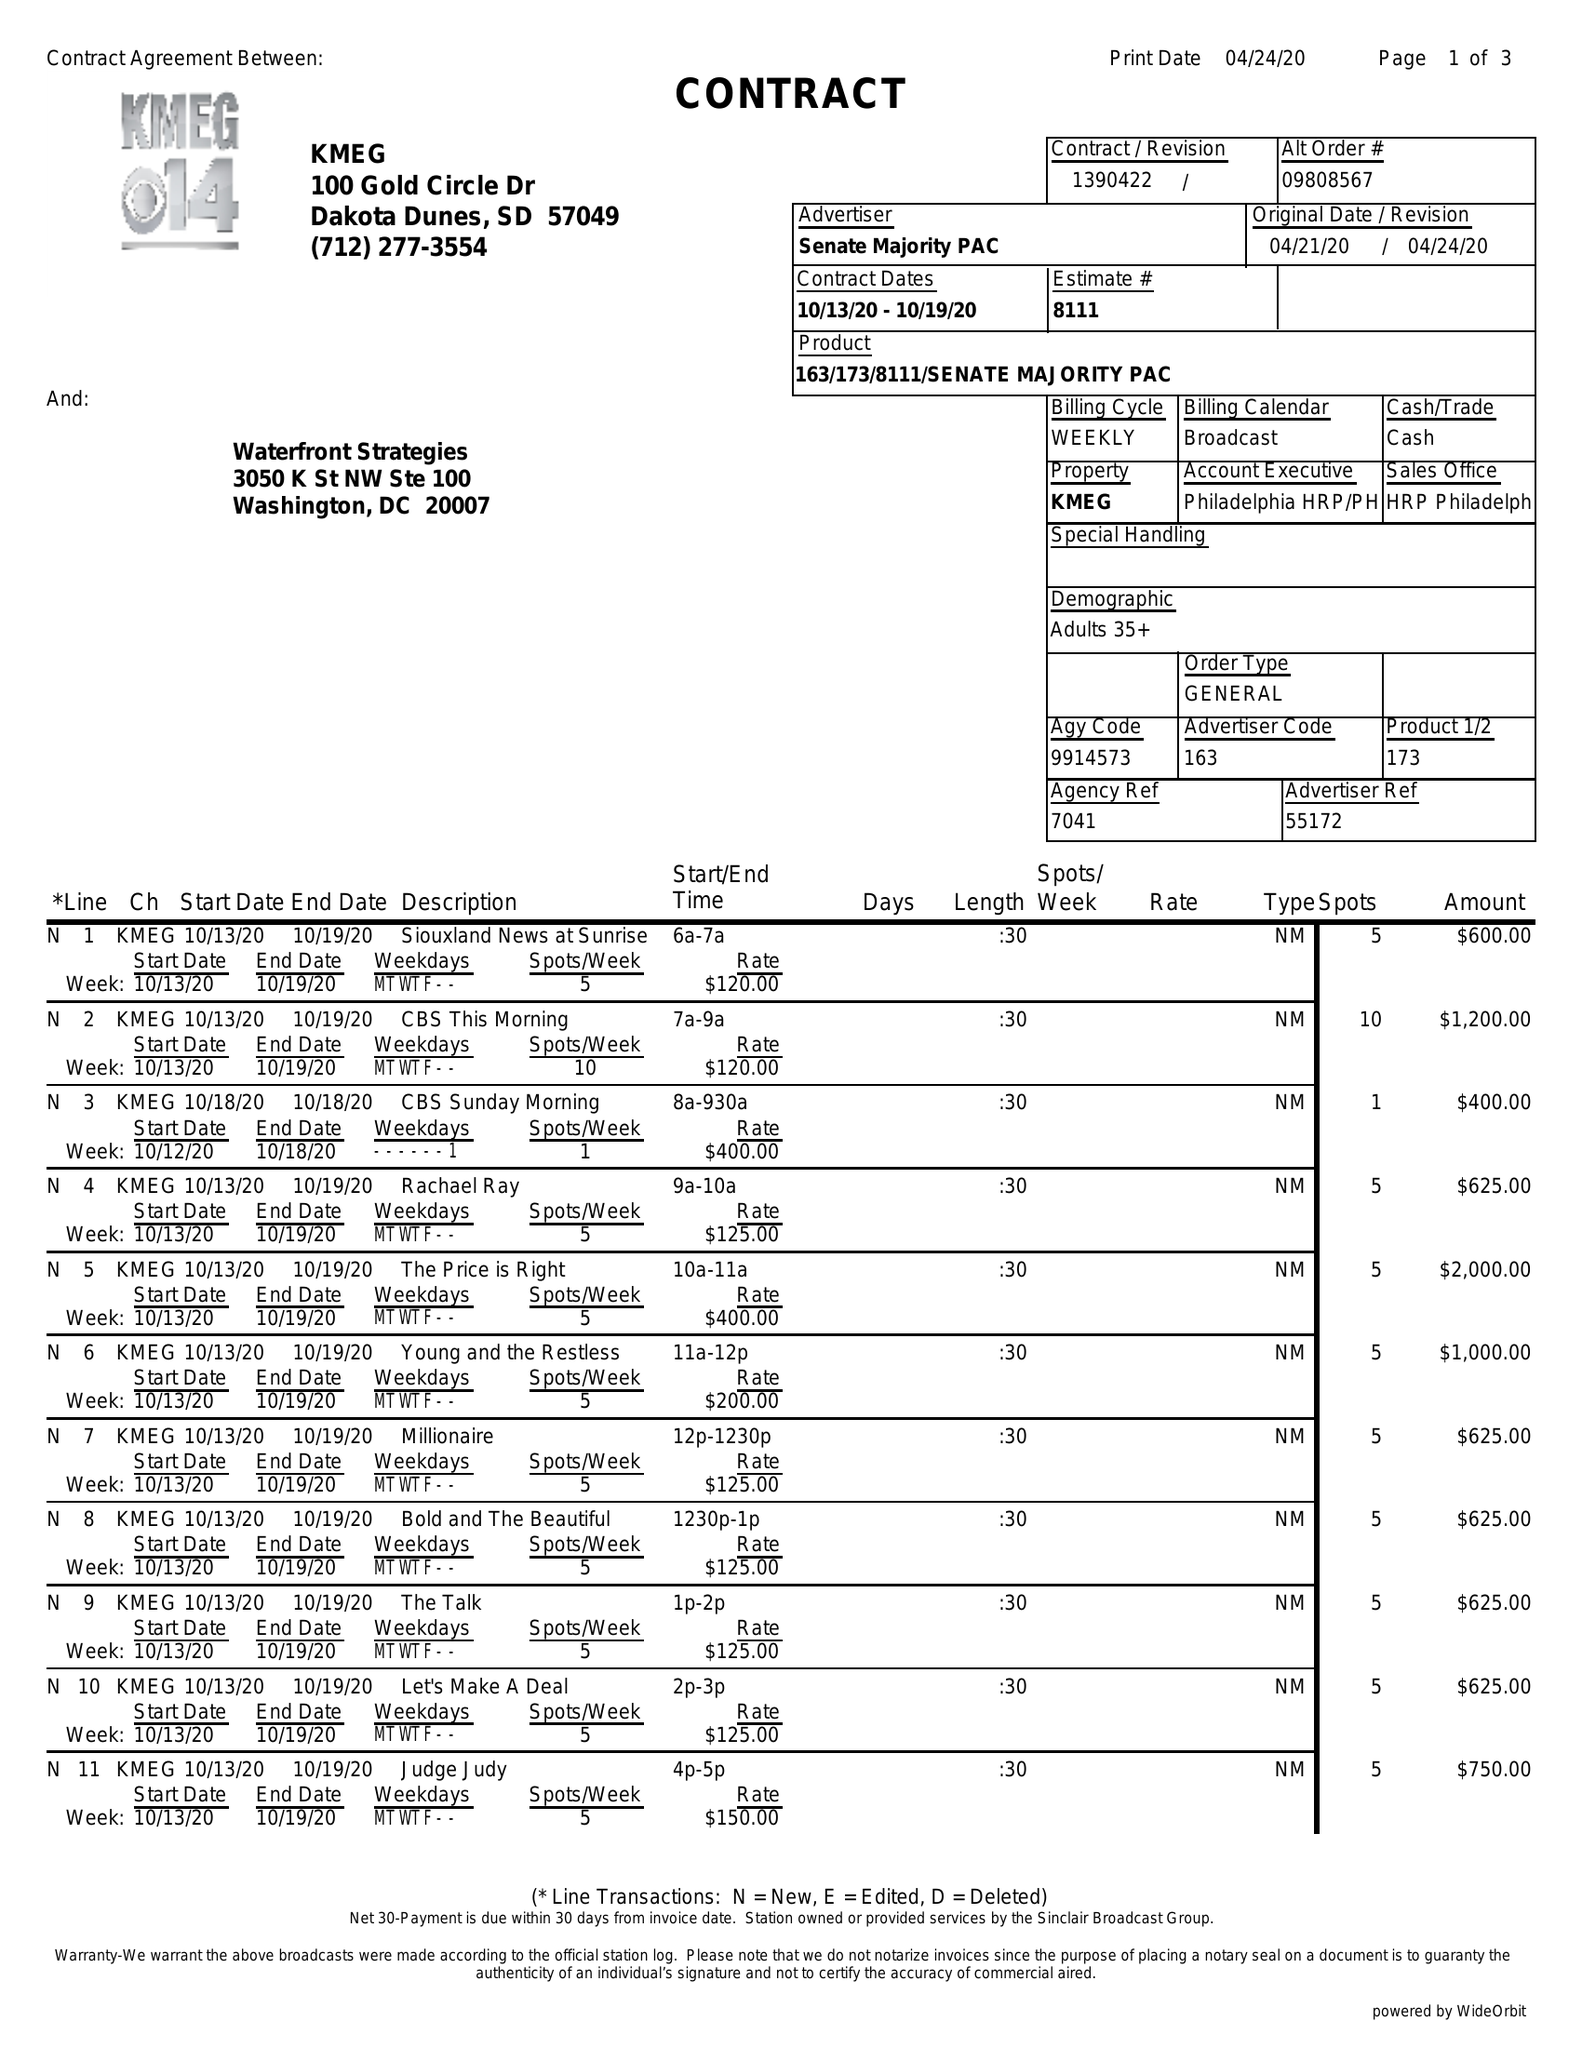What is the value for the flight_from?
Answer the question using a single word or phrase. 10/13/20 